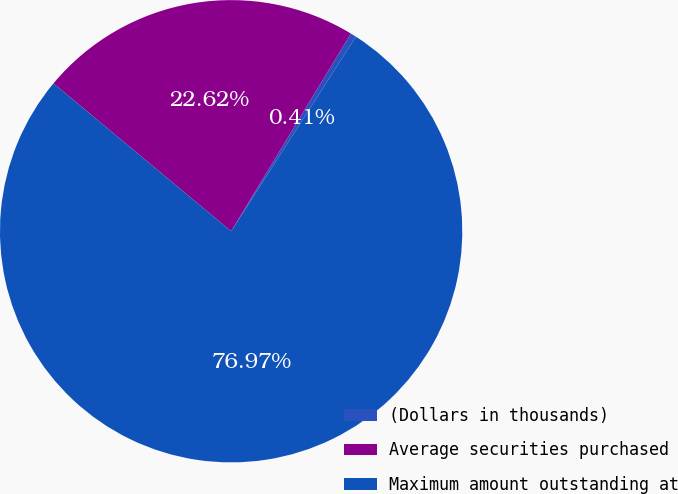Convert chart to OTSL. <chart><loc_0><loc_0><loc_500><loc_500><pie_chart><fcel>(Dollars in thousands)<fcel>Average securities purchased<fcel>Maximum amount outstanding at<nl><fcel>0.41%<fcel>22.62%<fcel>76.97%<nl></chart> 